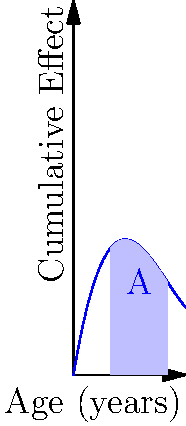The graph represents the cumulative effect of positive mental health interventions in early childhood. The x-axis represents the child's age in years, and the y-axis represents the cumulative effect of interventions. The shaded area A under the curve between ages 2 and 5 represents the total impact of interventions during this period. If the function of the curve is given by $f(x) = 0.1x^3 - 1.5x^2 + 6x$, calculate the total impact (area A) of interventions between ages 2 and 5. To find the area under the curve, we need to calculate the definite integral of the function $f(x) = 0.1x^3 - 1.5x^2 + 6x$ from x = 2 to x = 5.

Step 1: Set up the definite integral
$$A = \int_{2}^{5} (0.1x^3 - 1.5x^2 + 6x) dx$$

Step 2: Integrate the function
$$A = [\frac{0.1x^4}{4} - \frac{1.5x^3}{3} + 3x^2]_{2}^{5}$$

Step 3: Evaluate the integral at the upper and lower bounds
Upper bound (x = 5):
$$\frac{0.1(5^4)}{4} - \frac{1.5(5^3)}{3} + 3(5^2) = 31.25 - 62.5 + 75 = 43.75$$

Lower bound (x = 2):
$$\frac{0.1(2^4)}{4} - \frac{1.5(2^3)}{3} + 3(2^2) = 0.8 - 4 + 12 = 8.8$$

Step 4: Subtract the lower bound from the upper bound
$$A = 43.75 - 8.8 = 34.95$$

Therefore, the total impact (area A) of interventions between ages 2 and 5 is 34.95 units.
Answer: 34.95 units 